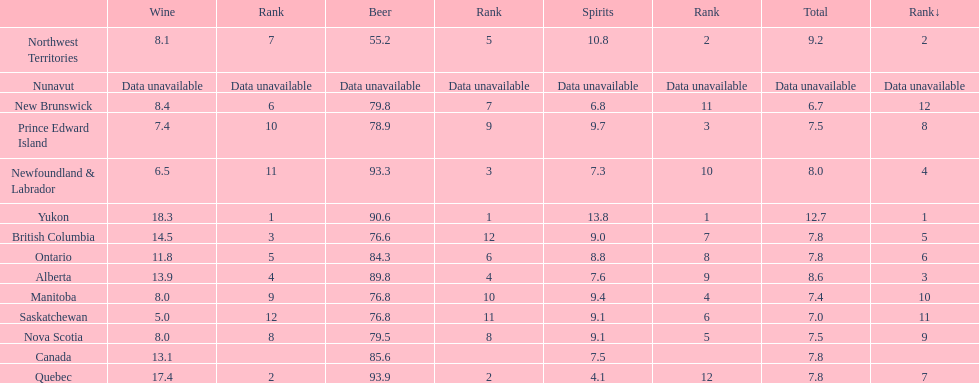Which country ranks #1 in alcoholic beverage consumption? Yukon. Of that country, how many total liters of spirits do they consume? 12.7. 